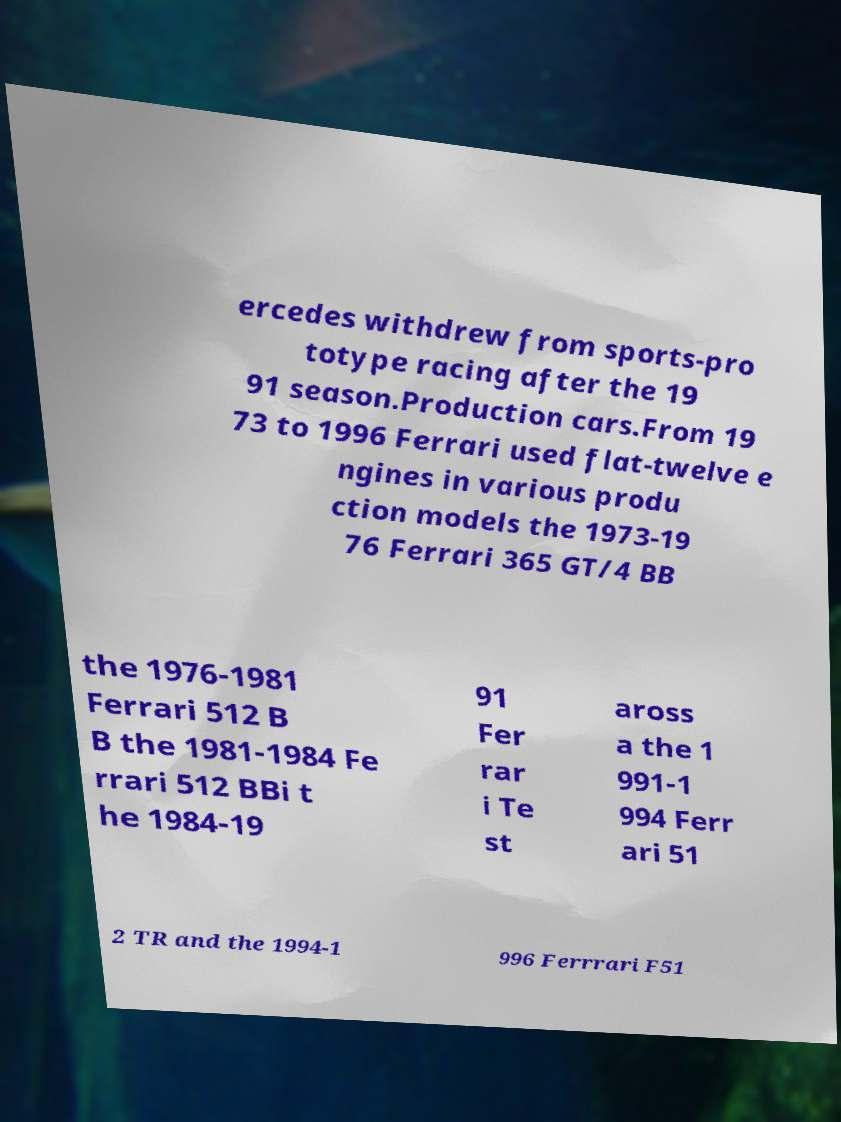I need the written content from this picture converted into text. Can you do that? ercedes withdrew from sports-pro totype racing after the 19 91 season.Production cars.From 19 73 to 1996 Ferrari used flat-twelve e ngines in various produ ction models the 1973-19 76 Ferrari 365 GT/4 BB the 1976-1981 Ferrari 512 B B the 1981-1984 Fe rrari 512 BBi t he 1984-19 91 Fer rar i Te st aross a the 1 991-1 994 Ferr ari 51 2 TR and the 1994-1 996 Ferrrari F51 